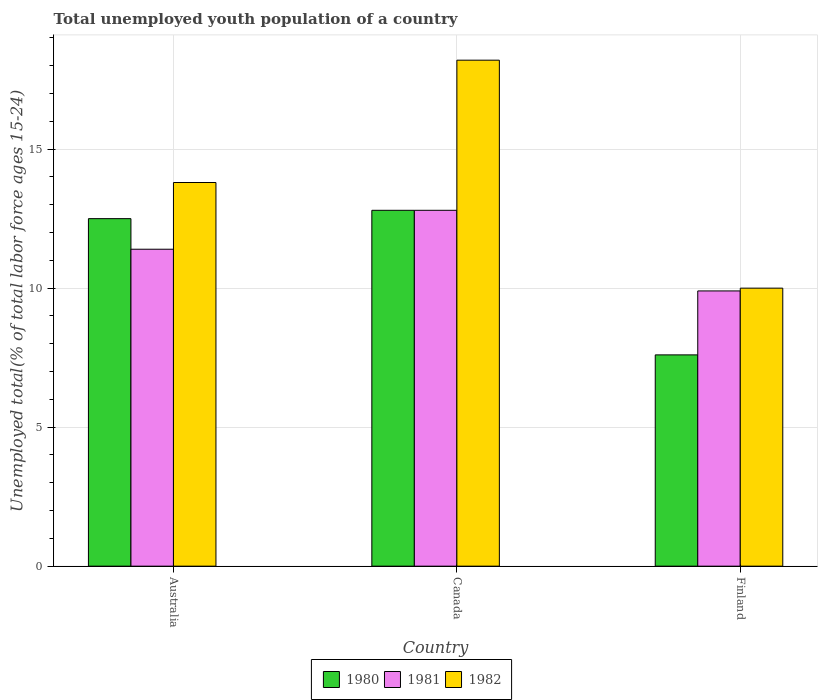How many different coloured bars are there?
Offer a terse response. 3. How many groups of bars are there?
Ensure brevity in your answer.  3. Are the number of bars on each tick of the X-axis equal?
Keep it short and to the point. Yes. What is the label of the 1st group of bars from the left?
Provide a succinct answer. Australia. In how many cases, is the number of bars for a given country not equal to the number of legend labels?
Provide a short and direct response. 0. What is the percentage of total unemployed youth population of a country in 1981 in Finland?
Offer a terse response. 9.9. Across all countries, what is the maximum percentage of total unemployed youth population of a country in 1980?
Offer a terse response. 12.8. Across all countries, what is the minimum percentage of total unemployed youth population of a country in 1980?
Your answer should be compact. 7.6. What is the total percentage of total unemployed youth population of a country in 1981 in the graph?
Keep it short and to the point. 34.1. What is the difference between the percentage of total unemployed youth population of a country in 1981 in Australia and that in Canada?
Make the answer very short. -1.4. What is the difference between the percentage of total unemployed youth population of a country in 1981 in Canada and the percentage of total unemployed youth population of a country in 1982 in Finland?
Provide a short and direct response. 2.8. What is the average percentage of total unemployed youth population of a country in 1980 per country?
Offer a very short reply. 10.97. What is the difference between the percentage of total unemployed youth population of a country of/in 1980 and percentage of total unemployed youth population of a country of/in 1981 in Finland?
Your answer should be very brief. -2.3. What is the ratio of the percentage of total unemployed youth population of a country in 1982 in Australia to that in Canada?
Your response must be concise. 0.76. Is the percentage of total unemployed youth population of a country in 1981 in Australia less than that in Canada?
Your answer should be very brief. Yes. What is the difference between the highest and the second highest percentage of total unemployed youth population of a country in 1982?
Ensure brevity in your answer.  8.2. What is the difference between the highest and the lowest percentage of total unemployed youth population of a country in 1980?
Your answer should be very brief. 5.2. In how many countries, is the percentage of total unemployed youth population of a country in 1981 greater than the average percentage of total unemployed youth population of a country in 1981 taken over all countries?
Your answer should be very brief. 2. Is the sum of the percentage of total unemployed youth population of a country in 1982 in Australia and Canada greater than the maximum percentage of total unemployed youth population of a country in 1980 across all countries?
Provide a short and direct response. Yes. What does the 1st bar from the left in Australia represents?
Make the answer very short. 1980. What does the 1st bar from the right in Canada represents?
Ensure brevity in your answer.  1982. How many countries are there in the graph?
Give a very brief answer. 3. What is the difference between two consecutive major ticks on the Y-axis?
Your response must be concise. 5. Where does the legend appear in the graph?
Provide a succinct answer. Bottom center. What is the title of the graph?
Give a very brief answer. Total unemployed youth population of a country. Does "2011" appear as one of the legend labels in the graph?
Keep it short and to the point. No. What is the label or title of the Y-axis?
Provide a succinct answer. Unemployed total(% of total labor force ages 15-24). What is the Unemployed total(% of total labor force ages 15-24) in 1980 in Australia?
Offer a very short reply. 12.5. What is the Unemployed total(% of total labor force ages 15-24) in 1981 in Australia?
Your response must be concise. 11.4. What is the Unemployed total(% of total labor force ages 15-24) in 1982 in Australia?
Offer a terse response. 13.8. What is the Unemployed total(% of total labor force ages 15-24) of 1980 in Canada?
Offer a very short reply. 12.8. What is the Unemployed total(% of total labor force ages 15-24) of 1981 in Canada?
Provide a short and direct response. 12.8. What is the Unemployed total(% of total labor force ages 15-24) in 1982 in Canada?
Provide a short and direct response. 18.2. What is the Unemployed total(% of total labor force ages 15-24) in 1980 in Finland?
Offer a terse response. 7.6. What is the Unemployed total(% of total labor force ages 15-24) of 1981 in Finland?
Provide a short and direct response. 9.9. What is the Unemployed total(% of total labor force ages 15-24) in 1982 in Finland?
Provide a succinct answer. 10. Across all countries, what is the maximum Unemployed total(% of total labor force ages 15-24) in 1980?
Your answer should be compact. 12.8. Across all countries, what is the maximum Unemployed total(% of total labor force ages 15-24) in 1981?
Provide a succinct answer. 12.8. Across all countries, what is the maximum Unemployed total(% of total labor force ages 15-24) of 1982?
Make the answer very short. 18.2. Across all countries, what is the minimum Unemployed total(% of total labor force ages 15-24) in 1980?
Offer a terse response. 7.6. Across all countries, what is the minimum Unemployed total(% of total labor force ages 15-24) of 1981?
Provide a succinct answer. 9.9. Across all countries, what is the minimum Unemployed total(% of total labor force ages 15-24) of 1982?
Your response must be concise. 10. What is the total Unemployed total(% of total labor force ages 15-24) in 1980 in the graph?
Offer a terse response. 32.9. What is the total Unemployed total(% of total labor force ages 15-24) in 1981 in the graph?
Keep it short and to the point. 34.1. What is the difference between the Unemployed total(% of total labor force ages 15-24) in 1980 in Australia and that in Canada?
Your response must be concise. -0.3. What is the difference between the Unemployed total(% of total labor force ages 15-24) in 1981 in Australia and that in Canada?
Offer a terse response. -1.4. What is the difference between the Unemployed total(% of total labor force ages 15-24) of 1982 in Australia and that in Canada?
Give a very brief answer. -4.4. What is the difference between the Unemployed total(% of total labor force ages 15-24) of 1980 in Australia and that in Finland?
Your response must be concise. 4.9. What is the difference between the Unemployed total(% of total labor force ages 15-24) of 1980 in Canada and that in Finland?
Offer a very short reply. 5.2. What is the difference between the Unemployed total(% of total labor force ages 15-24) of 1982 in Canada and that in Finland?
Ensure brevity in your answer.  8.2. What is the difference between the Unemployed total(% of total labor force ages 15-24) in 1981 in Australia and the Unemployed total(% of total labor force ages 15-24) in 1982 in Canada?
Keep it short and to the point. -6.8. What is the difference between the Unemployed total(% of total labor force ages 15-24) in 1980 in Canada and the Unemployed total(% of total labor force ages 15-24) in 1982 in Finland?
Make the answer very short. 2.8. What is the difference between the Unemployed total(% of total labor force ages 15-24) of 1981 in Canada and the Unemployed total(% of total labor force ages 15-24) of 1982 in Finland?
Provide a short and direct response. 2.8. What is the average Unemployed total(% of total labor force ages 15-24) in 1980 per country?
Your answer should be very brief. 10.97. What is the average Unemployed total(% of total labor force ages 15-24) of 1981 per country?
Your answer should be very brief. 11.37. What is the average Unemployed total(% of total labor force ages 15-24) in 1982 per country?
Your answer should be compact. 14. What is the difference between the Unemployed total(% of total labor force ages 15-24) of 1980 and Unemployed total(% of total labor force ages 15-24) of 1982 in Finland?
Keep it short and to the point. -2.4. What is the ratio of the Unemployed total(% of total labor force ages 15-24) of 1980 in Australia to that in Canada?
Your answer should be compact. 0.98. What is the ratio of the Unemployed total(% of total labor force ages 15-24) in 1981 in Australia to that in Canada?
Give a very brief answer. 0.89. What is the ratio of the Unemployed total(% of total labor force ages 15-24) of 1982 in Australia to that in Canada?
Give a very brief answer. 0.76. What is the ratio of the Unemployed total(% of total labor force ages 15-24) in 1980 in Australia to that in Finland?
Keep it short and to the point. 1.64. What is the ratio of the Unemployed total(% of total labor force ages 15-24) of 1981 in Australia to that in Finland?
Keep it short and to the point. 1.15. What is the ratio of the Unemployed total(% of total labor force ages 15-24) in 1982 in Australia to that in Finland?
Make the answer very short. 1.38. What is the ratio of the Unemployed total(% of total labor force ages 15-24) of 1980 in Canada to that in Finland?
Ensure brevity in your answer.  1.68. What is the ratio of the Unemployed total(% of total labor force ages 15-24) of 1981 in Canada to that in Finland?
Make the answer very short. 1.29. What is the ratio of the Unemployed total(% of total labor force ages 15-24) in 1982 in Canada to that in Finland?
Offer a terse response. 1.82. What is the difference between the highest and the second highest Unemployed total(% of total labor force ages 15-24) of 1980?
Provide a short and direct response. 0.3. What is the difference between the highest and the lowest Unemployed total(% of total labor force ages 15-24) of 1982?
Your response must be concise. 8.2. 